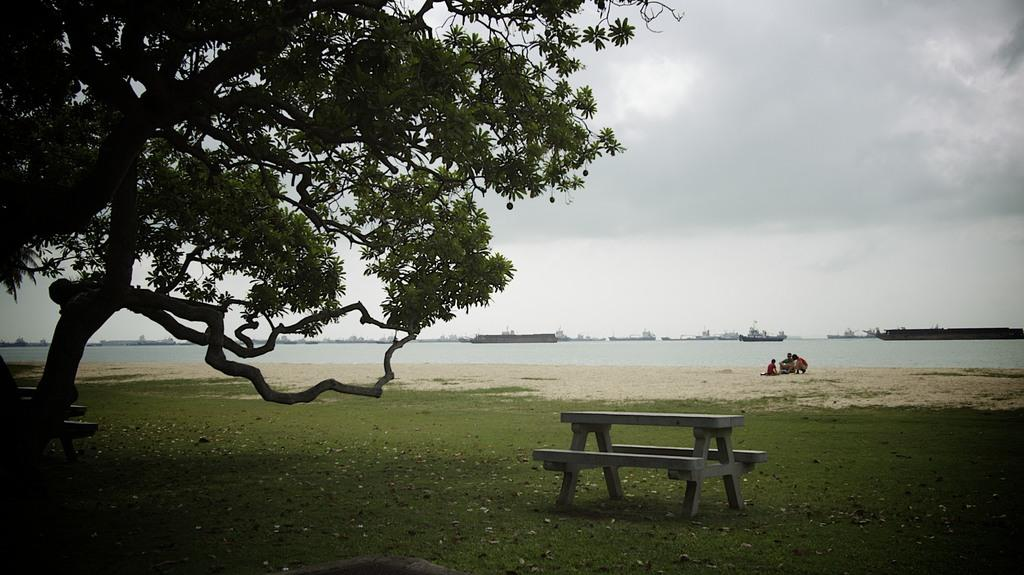How many people are in the image? There are three persons in the image. What type of seating is present in the image? There are benches in the image. What type of vegetation is visible in the image? There is grass in the image. What type of plant is visible in the image? There is a tree in the image. What can be seen in the water in the image? Ships are visible in the water. What is visible in the background of the image? There is sky visible in the background of the image. What type of kettle is being used to make a request in the image? There is no kettle or request present in the image. What type of board is being used by the persons in the image? There is no board visible in the image; the persons are not engaging in any activities that would require a board. 